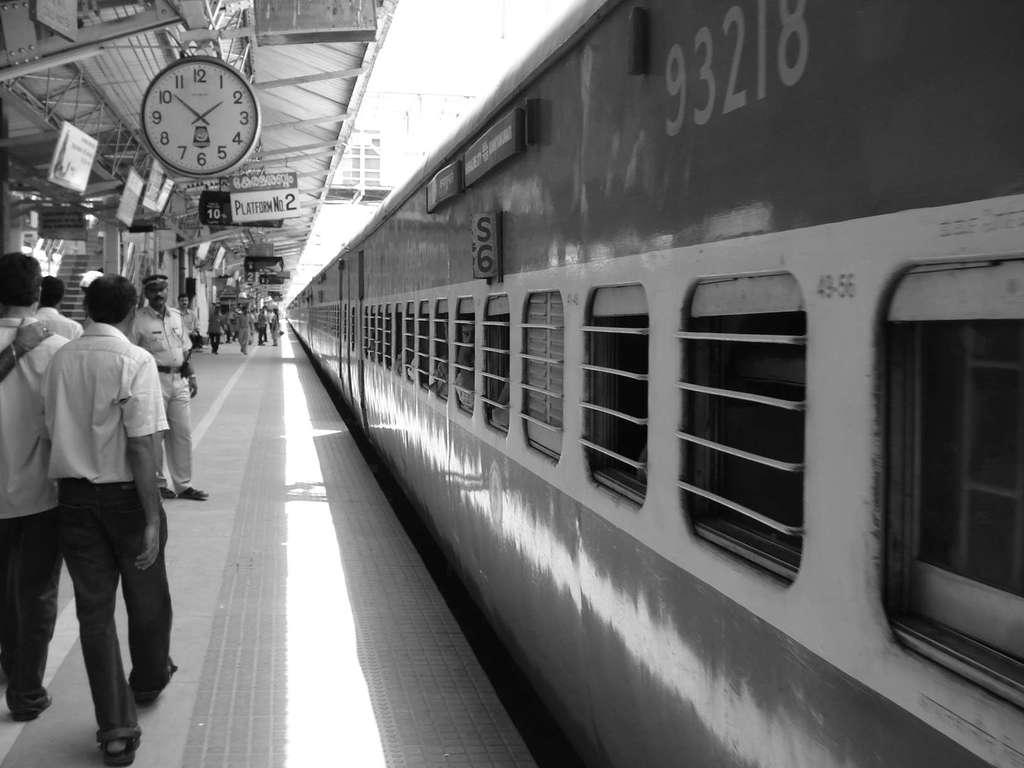Where was the image taken? The image was taken on a platform. What can be seen on the right side of the platform? There is a train on the right side of the platform. What is present on the left side of the platform? There are persons on the left side of the platform. Can you identify any time-keeping device in the image? Yes, there is a clock in the image. What architectural feature is visible in the image? There are stairs in the image. What type of structure is present in the background of the image? There is a shed in the image. What type of grain is being stored in the sofa in the image? There is no sofa or grain present in the image. What color is the powder that is visible on the train in the image? There is no powder visible on the train in the image. 